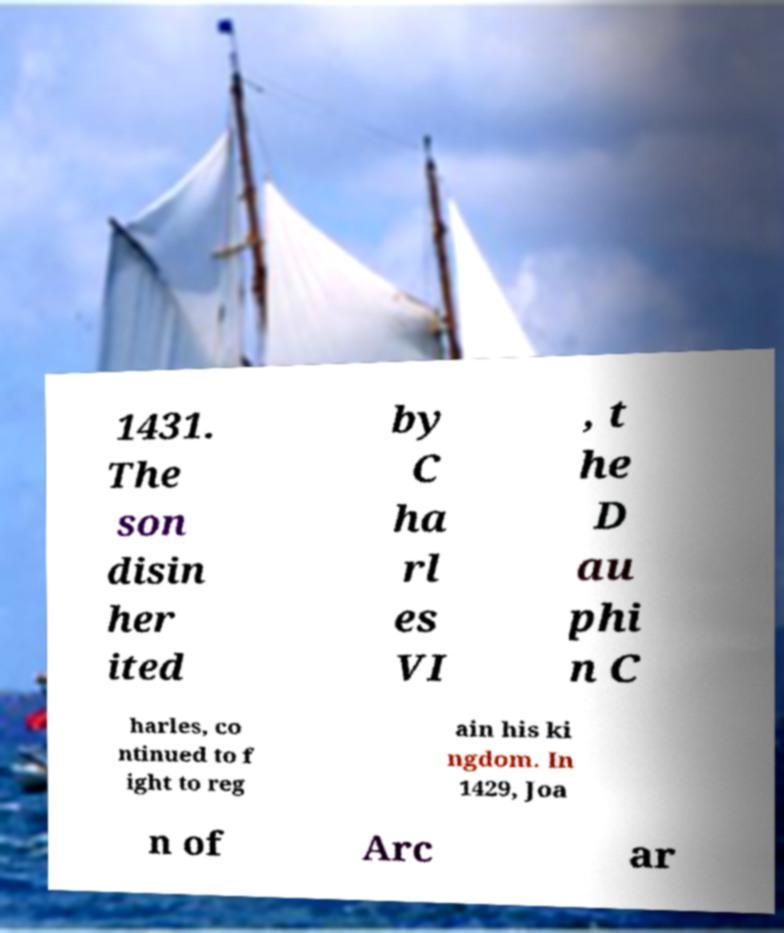Please identify and transcribe the text found in this image. 1431. The son disin her ited by C ha rl es VI , t he D au phi n C harles, co ntinued to f ight to reg ain his ki ngdom. In 1429, Joa n of Arc ar 